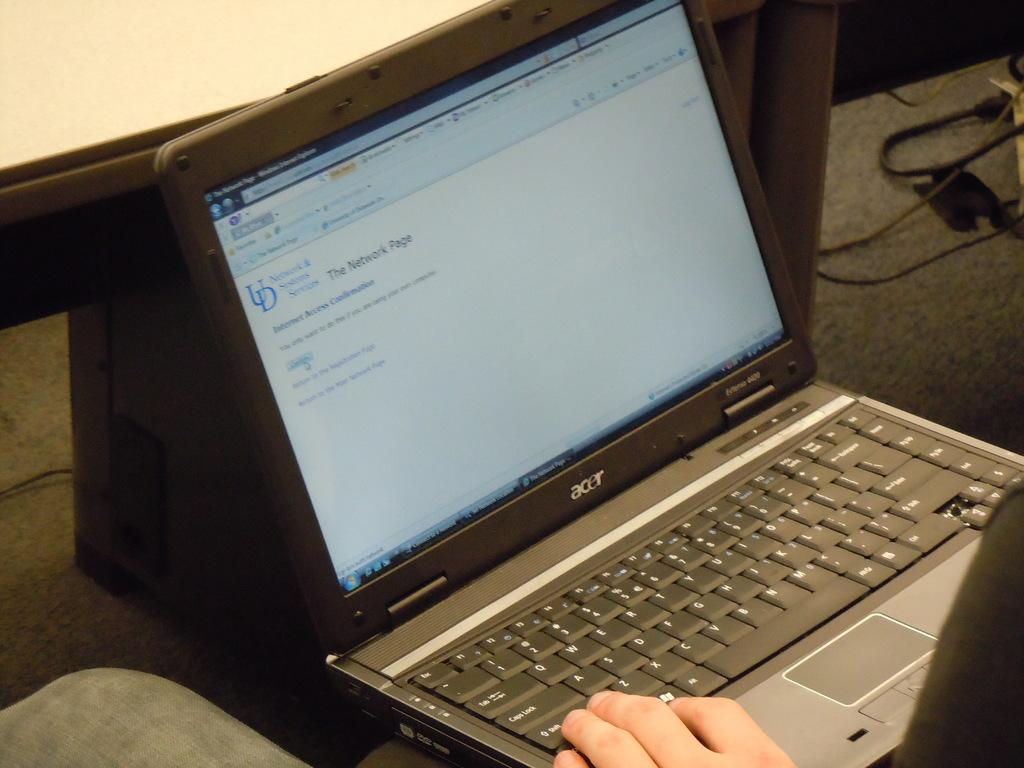<image>
Share a concise interpretation of the image provided. A laptop computer with the words, the network page, on the screen. 